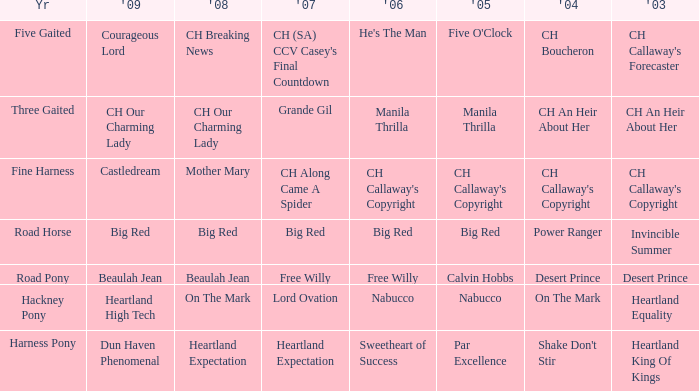What is the 2008 for 2009 heartland high tech? On The Mark. 